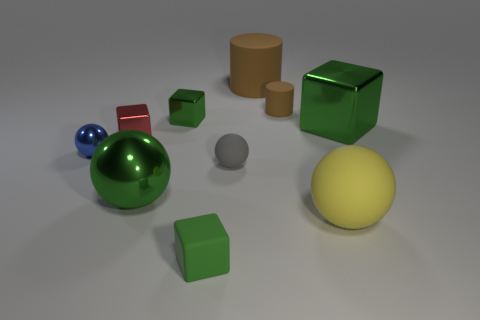The big cylinder is what color?
Offer a terse response. Brown. The small shiny thing that is the same color as the large metal sphere is what shape?
Provide a succinct answer. Cube. Are there any red metal objects?
Provide a short and direct response. Yes. There is a yellow ball that is the same material as the gray object; what size is it?
Offer a terse response. Large. The red thing on the left side of the small green thing behind the large green metallic thing behind the gray ball is what shape?
Provide a short and direct response. Cube. Are there an equal number of big metallic things that are left of the big green metallic ball and large metal balls?
Your answer should be very brief. No. The matte object that is the same color as the big metal ball is what size?
Ensure brevity in your answer.  Small. Do the small gray matte thing and the big brown thing have the same shape?
Offer a very short reply. No. How many objects are either big shiny things that are to the left of the big brown thing or big red metal things?
Your response must be concise. 1. Are there an equal number of blue spheres that are in front of the small green matte block and green spheres that are in front of the yellow rubber sphere?
Offer a terse response. Yes. 